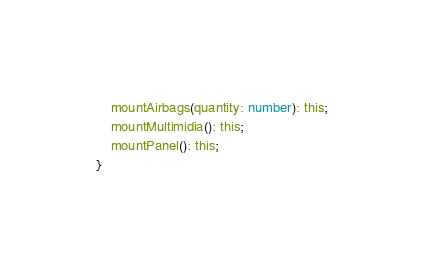<code> <loc_0><loc_0><loc_500><loc_500><_TypeScript_>    mountAirbags(quantity: number): this;
    mountMultimidia(): this;
    mountPanel(): this;
}</code> 